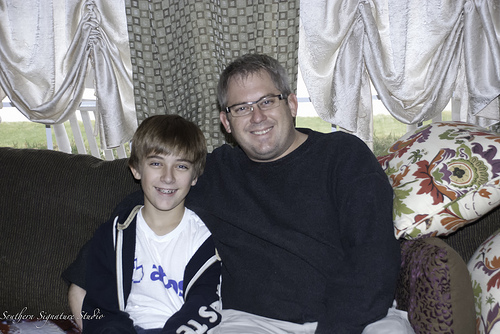<image>
Is there a man behind the boy? Yes. From this viewpoint, the man is positioned behind the boy, with the boy partially or fully occluding the man. 